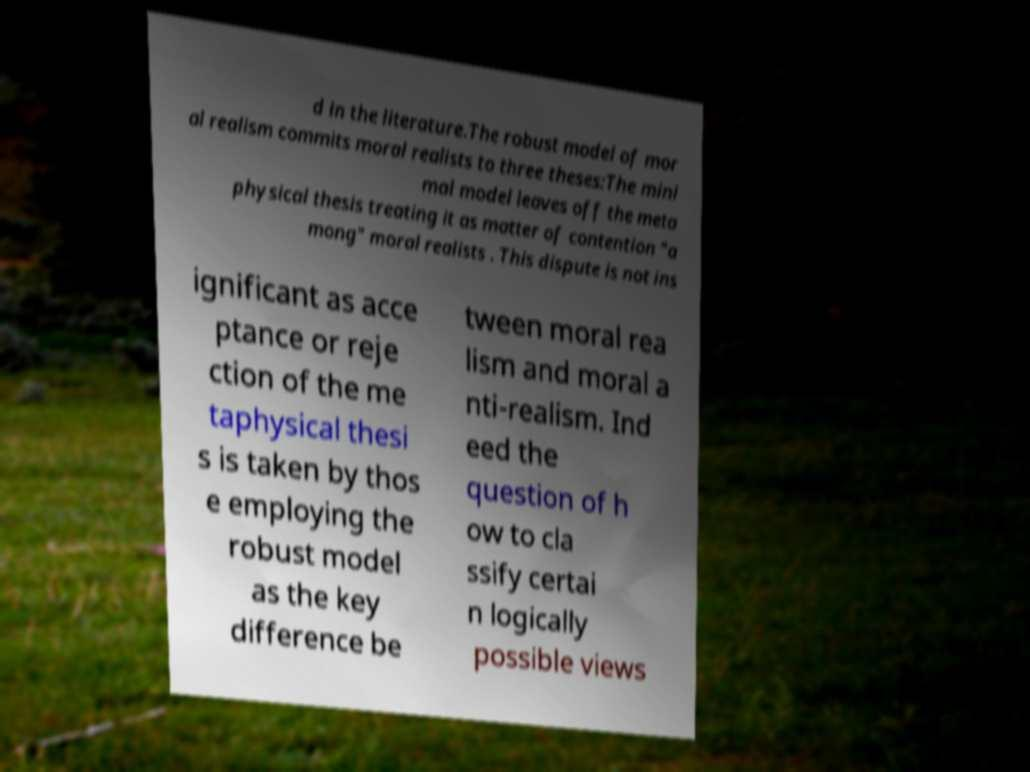Can you read and provide the text displayed in the image?This photo seems to have some interesting text. Can you extract and type it out for me? d in the literature.The robust model of mor al realism commits moral realists to three theses:The mini mal model leaves off the meta physical thesis treating it as matter of contention "a mong" moral realists . This dispute is not ins ignificant as acce ptance or reje ction of the me taphysical thesi s is taken by thos e employing the robust model as the key difference be tween moral rea lism and moral a nti-realism. Ind eed the question of h ow to cla ssify certai n logically possible views 